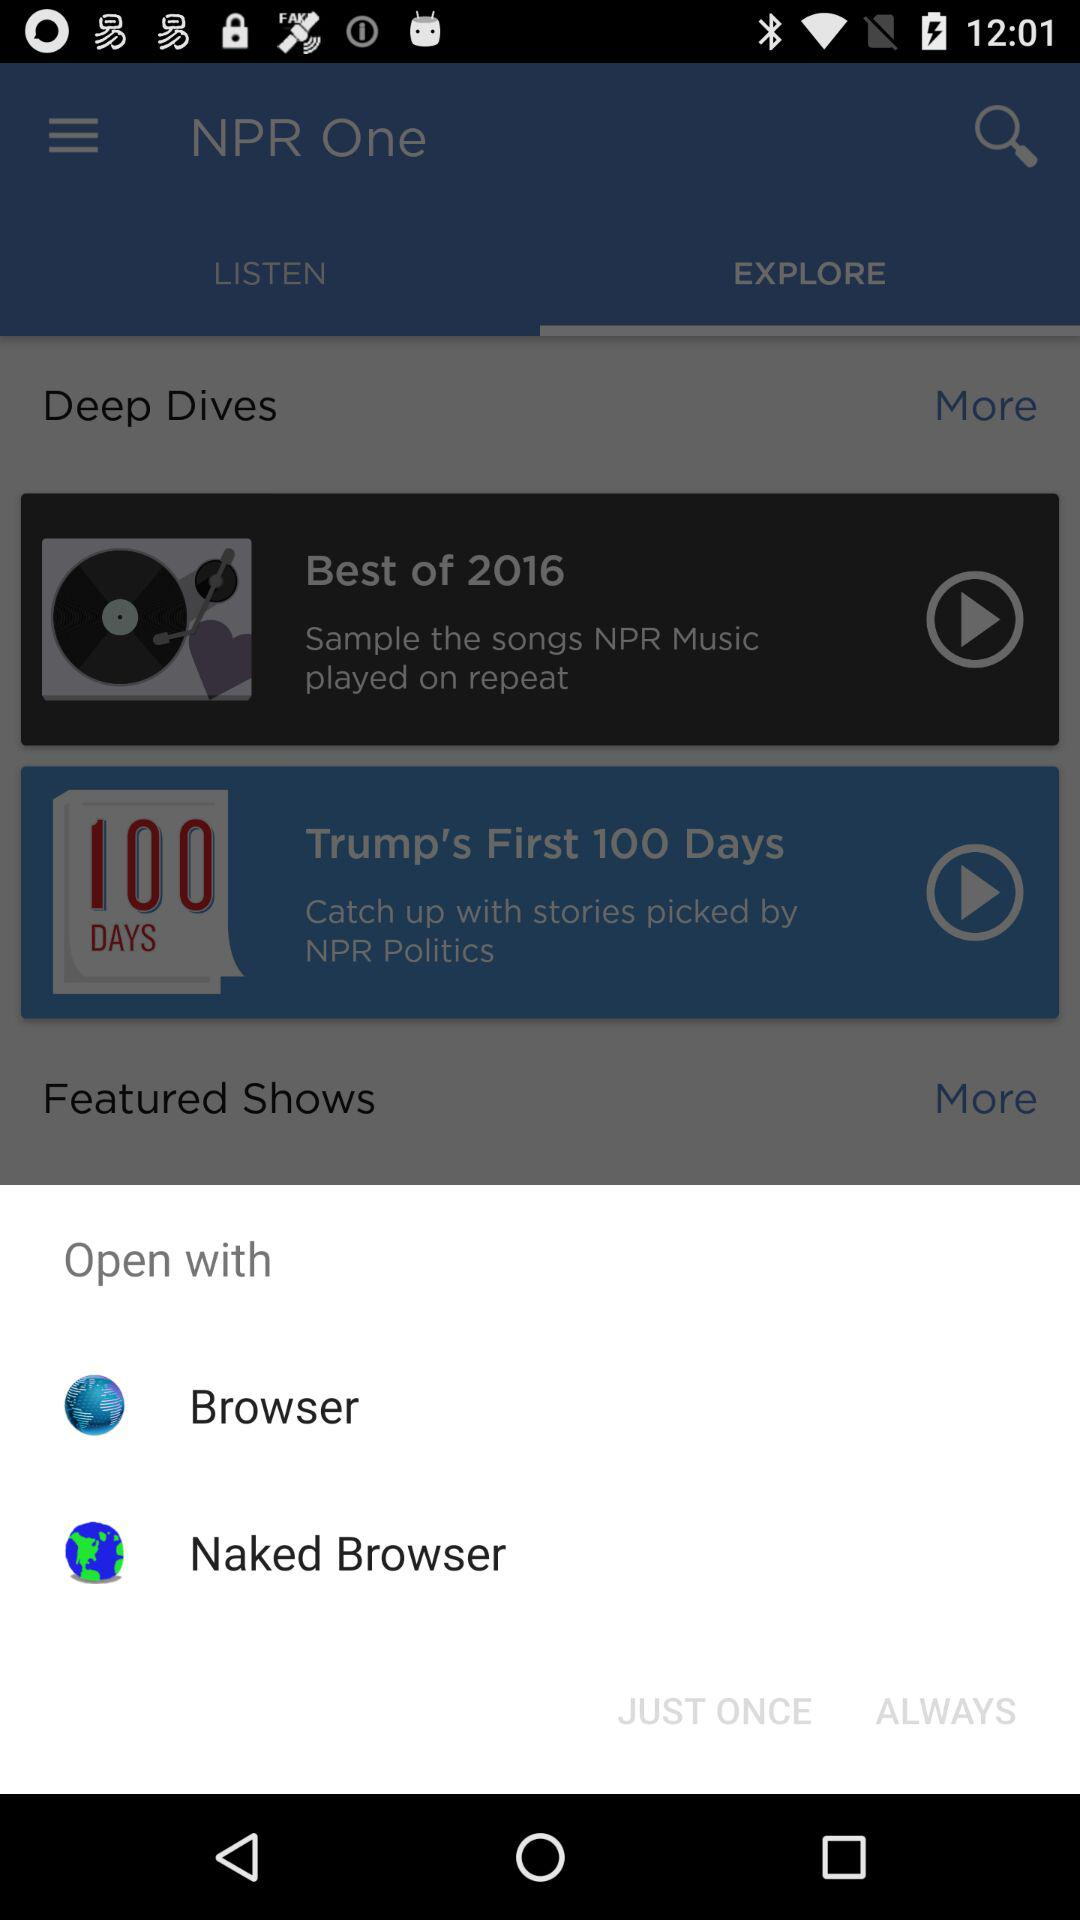How many items in the "Open with" section have a picture?
Answer the question using a single word or phrase. 2 